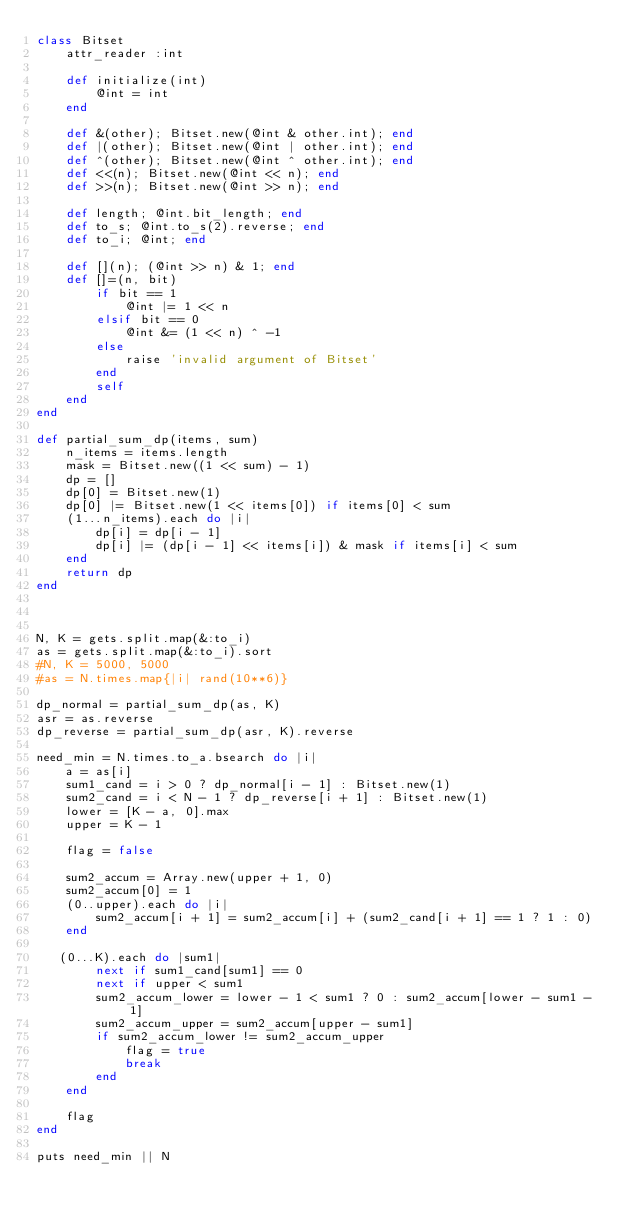Convert code to text. <code><loc_0><loc_0><loc_500><loc_500><_Ruby_>class Bitset
    attr_reader :int

    def initialize(int)
        @int = int
    end

    def &(other); Bitset.new(@int & other.int); end
    def |(other); Bitset.new(@int | other.int); end
    def ^(other); Bitset.new(@int ^ other.int); end
    def <<(n); Bitset.new(@int << n); end
    def >>(n); Bitset.new(@int >> n); end
    
    def length; @int.bit_length; end
    def to_s; @int.to_s(2).reverse; end
    def to_i; @int; end

    def [](n); (@int >> n) & 1; end
    def []=(n, bit)
        if bit == 1
            @int |= 1 << n
        elsif bit == 0
            @int &= (1 << n) ^ -1
        else
            raise 'invalid argument of Bitset'
        end
        self
    end
end

def partial_sum_dp(items, sum)
    n_items = items.length
    mask = Bitset.new((1 << sum) - 1)
    dp = []
    dp[0] = Bitset.new(1)
    dp[0] |= Bitset.new(1 << items[0]) if items[0] < sum
    (1...n_items).each do |i|
        dp[i] = dp[i - 1]
        dp[i] |= (dp[i - 1] << items[i]) & mask if items[i] < sum
    end
    return dp
end



N, K = gets.split.map(&:to_i)
as = gets.split.map(&:to_i).sort
#N, K = 5000, 5000
#as = N.times.map{|i| rand(10**6)}

dp_normal = partial_sum_dp(as, K)
asr = as.reverse
dp_reverse = partial_sum_dp(asr, K).reverse

need_min = N.times.to_a.bsearch do |i|
    a = as[i]
    sum1_cand = i > 0 ? dp_normal[i - 1] : Bitset.new(1)
    sum2_cand = i < N - 1 ? dp_reverse[i + 1] : Bitset.new(1)
    lower = [K - a, 0].max
    upper = K - 1

    flag = false

    sum2_accum = Array.new(upper + 1, 0)
    sum2_accum[0] = 1
    (0..upper).each do |i|
        sum2_accum[i + 1] = sum2_accum[i] + (sum2_cand[i + 1] == 1 ? 1 : 0)
    end

   (0...K).each do |sum1|
        next if sum1_cand[sum1] == 0
        next if upper < sum1
        sum2_accum_lower = lower - 1 < sum1 ? 0 : sum2_accum[lower - sum1 - 1]
        sum2_accum_upper = sum2_accum[upper - sum1]
        if sum2_accum_lower != sum2_accum_upper
            flag = true
            break
        end
    end

    flag
end

puts need_min || N

</code> 